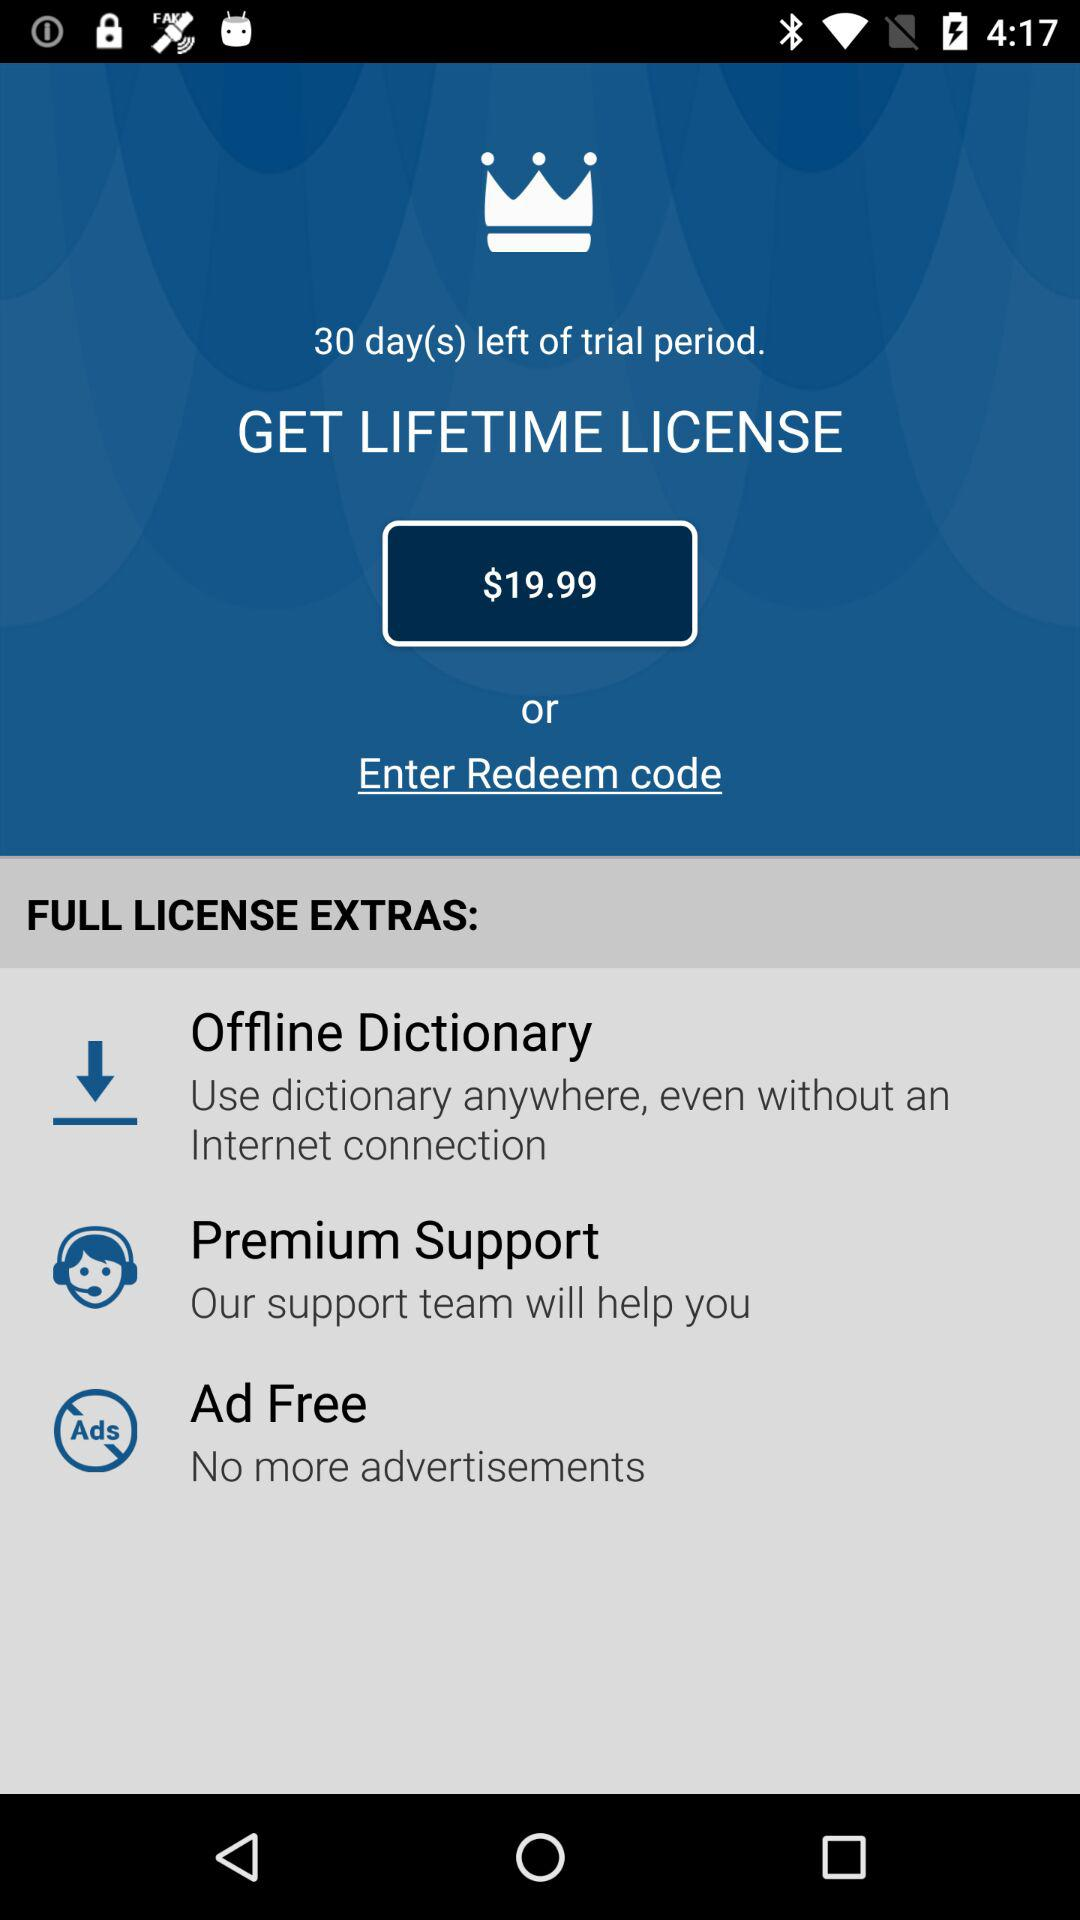How many days are left in the trial period? There are 30 days left in the trial period. 